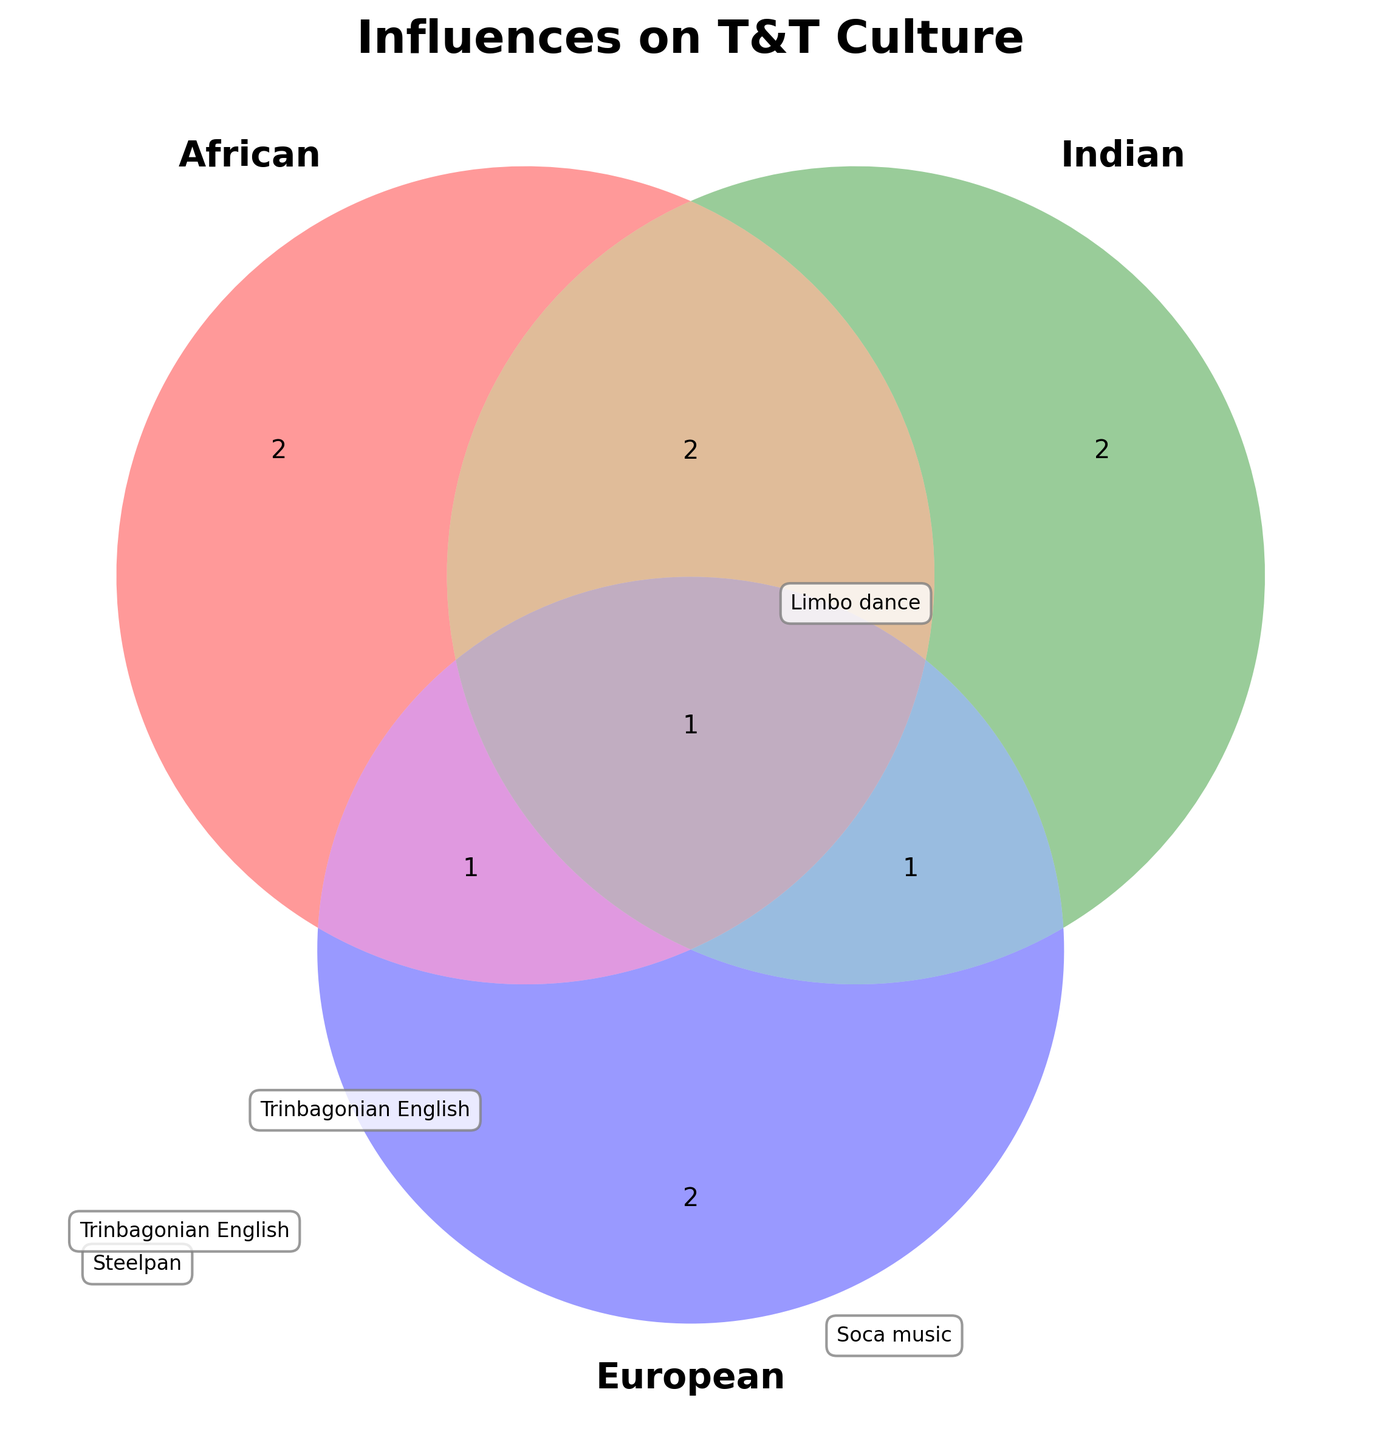Which African cultural elements are shown in the diagram? To identify African cultural elements, look for items located in the "African" section of the Venn diagram without any overlaps with Indian and European categories.
Answer: Calypso music, Limbo dance Which cultural elements are influenced by African and Indian cultures together? Look at the overlapping section between the African and Indian circles, but not overlapping with the European circle.
Answer: Soca music, Steelpan How many cultural elements are influenced solely by European culture? Identify the items in the European section without any overlaps with African or Indian categories.
Answer: Two What cultural elements are influenced by all three cultures: African, Indian, and European? Locate the central area where all three circles overlap.
Answer: Trinbagonian English Is there any cultural element shared between Indian and European but not African? Check the area where Indian and European circles overlap, excluding the African circle.
Answer: Rum production Which culture singularly influences Chutney music? Locate Chutney music in the diagram and identify the culture it corresponds to without any overlaps.
Answer: Indian Compare the number of cultural elements influenced solely by African culture to those influenced solely by Indian culture. Which is greater? Count the elements in the African section without overlaps and compare to the Indian section without overlaps. African has 2 elements (Calypso music and Limbo dance), and Indian has 2 elements (Doubles and Chutney music). Therefore, they are equal.
Answer: Equal What is the main title of the figure? Look at the top of the diagram to find the main title.
Answer: Influences on T&T Culture Which cultural elements are influenced by both African and European cultures together but not Indian? Look at the overlapping section between African and European circles, excluding the Indian circle.
Answer: Patois language 